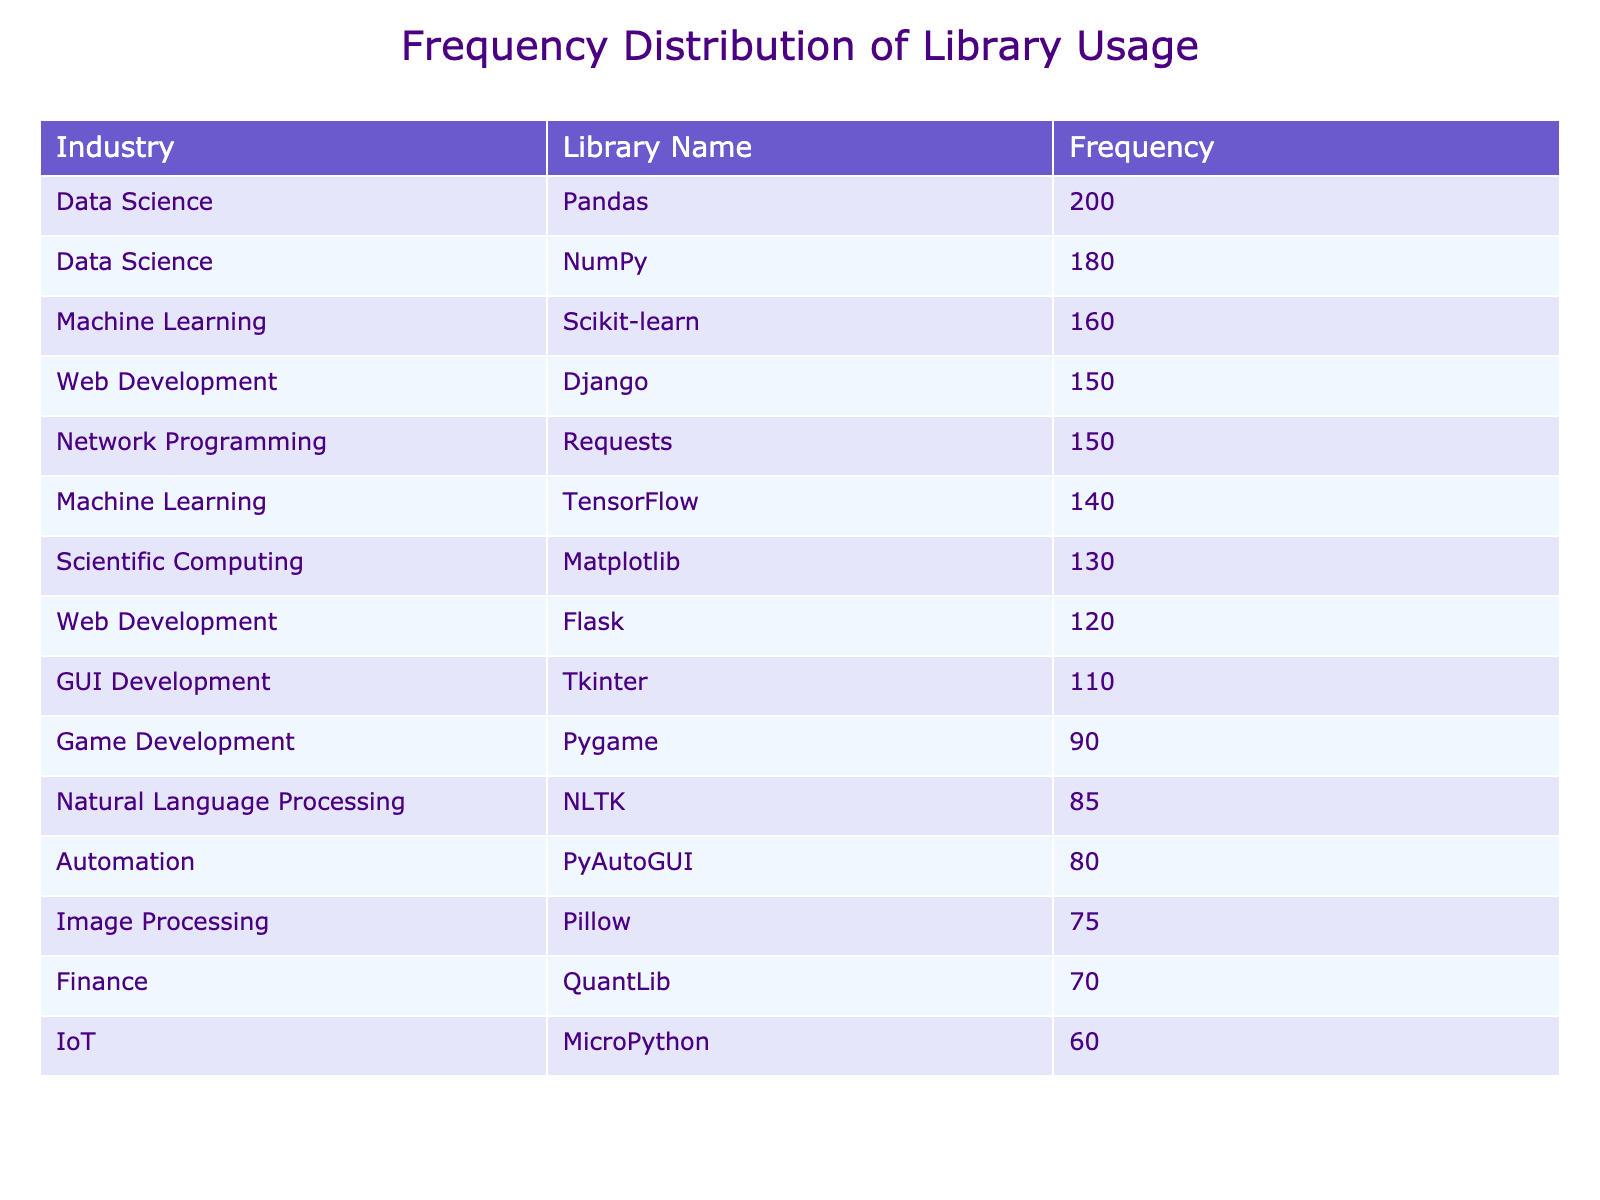What is the most frequently used library in Data Science? The table shows that among Data Science libraries, Pandas has the highest frequency with a count of 200.
Answer: 200 Which library is used more frequently in Web Development, Django or Flask? The table shows that Django has a frequency of 150 while Flask has a frequency of 120. Since 150 is greater than 120, Django is the more frequently used library.
Answer: Django What is the total frequency of libraries used in Machine Learning? The frequencies for Machine Learning libraries are Scikit-learn (160) and TensorFlow (140). Adding these gives 160 + 140 = 300.
Answer: 300 Is PyAutoGUI used more frequently than Pillow? The frequency for PyAutoGUI is 80 and for Pillow, it is 75. Since 80 is greater than 75, PyAutoGUI is used more frequently than Pillow.
Answer: Yes What is the average frequency of libraries in the Game Development and Automation industries? In Game Development, Pygame has a frequency of 90, and in Automation, PyAutoGUI has a frequency of 80. To find the average, add both frequencies: 90 + 80 = 170, then divide by 2: 170 / 2 = 85.
Answer: 85 Which library has the lowest usage frequency and what is that frequency? By inspecting the table, MicroPython has the lowest frequency with a count of 60.
Answer: 60 How many libraries have a frequency greater than 100? The libraries with frequencies above 100 are: Pandas (200), NumPy (180), Scikit-learn (160), TensorFlow (140), Django (150), and Matplotlib (130). Counting these gives a total of 6 libraries.
Answer: 6 Which industry uses the most libraries overall and how many libraries does it utilize? By looking at the table, Data Science has 2 libraries (Pandas and NumPy), Web Development has 2 libraries (Django and Flask), Machine Learning has 2 libraries (Scikit-learn and TensorFlow), Game Development has 1 library (Pygame), Finance has 1 library (QuantLib), Automation has 1 library (PyAutoGUI), IoT has 1 library (MicroPython), Scientific Computing has 1 library (Matplotlib), GUI Development has 1 library (Tkinter), Network Programming has 1 library (Requests), Image Processing has 1 library (Pillow), and Natural Language Processing has 1 library (NLTK). All industries except Data Science have 1 or 2 libraries, making Data Science the industry with the most library usage.
Answer: Data Science, 2 What is the difference in the frequency of the most used library in Automation compared to the most used library in Finance? The most used library in Automation (PyAutoGUI) has a frequency of 80, while the most used library in Finance (QuantLib) has a frequency of 70. The difference is calculated by subtracting 70 from 80, giving 80 - 70 = 10.
Answer: 10 